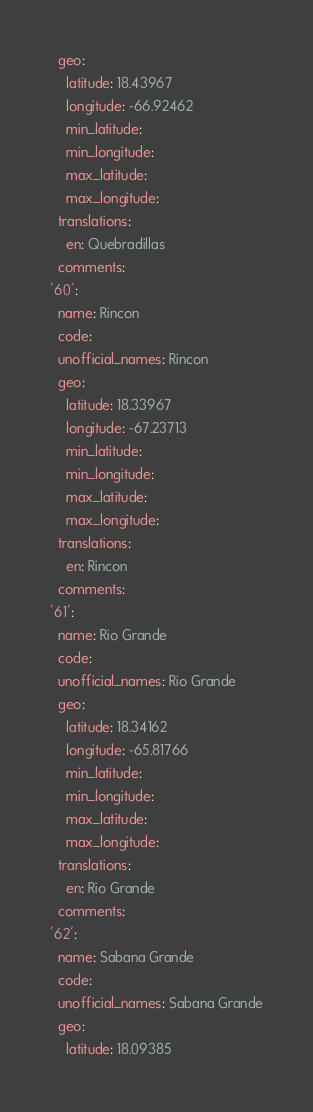Convert code to text. <code><loc_0><loc_0><loc_500><loc_500><_YAML_>  geo:
    latitude: 18.43967
    longitude: -66.92462
    min_latitude: 
    min_longitude: 
    max_latitude: 
    max_longitude: 
  translations:
    en: Quebradillas
  comments: 
'60': 
  name: Rincon
  code: 
  unofficial_names: Rincon
  geo:
    latitude: 18.33967
    longitude: -67.23713
    min_latitude: 
    min_longitude: 
    max_latitude: 
    max_longitude: 
  translations:
    en: Rincon
  comments: 
'61': 
  name: Rio Grande
  code: 
  unofficial_names: Rio Grande
  geo:
    latitude: 18.34162
    longitude: -65.81766
    min_latitude: 
    min_longitude: 
    max_latitude: 
    max_longitude: 
  translations:
    en: Rio Grande
  comments: 
'62': 
  name: Sabana Grande
  code: 
  unofficial_names: Sabana Grande
  geo:
    latitude: 18.09385</code> 